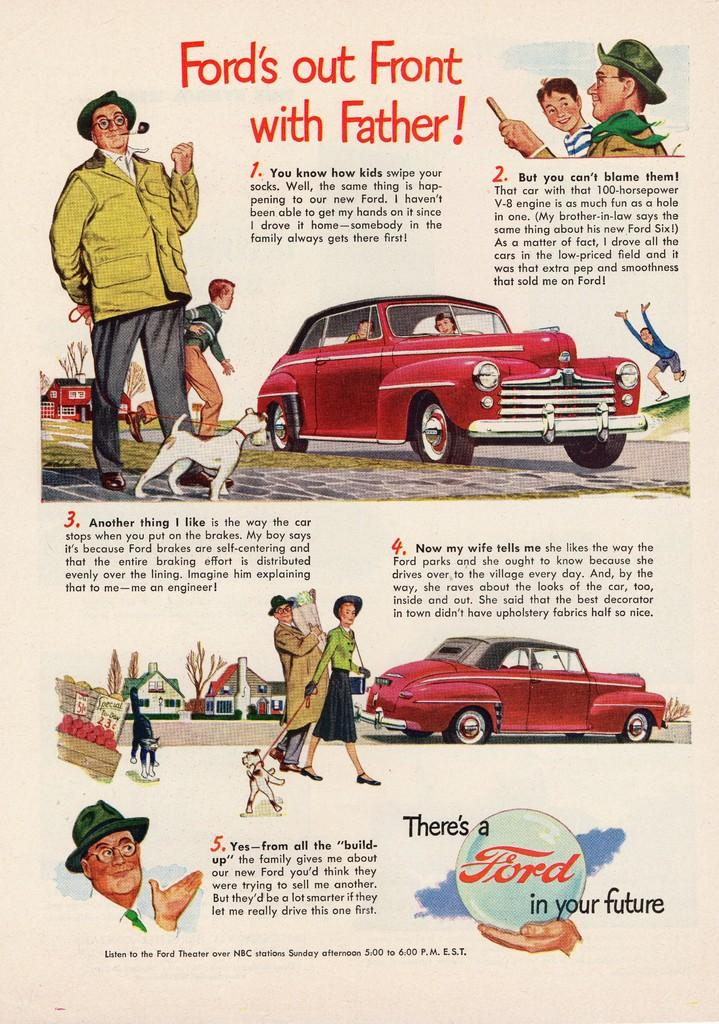What is present on the poster in the image? There is a poster in the image that contains images and text. Can you describe the images on the poster? Unfortunately, the specific images on the poster cannot be described without more information. What type of information is conveyed through the text on the poster? The content of the text on the poster cannot be determined without more information. What color is the zipper on the leg of the person in the image? There is no person or zipper present in the image; it only contains a poster with images and text. 